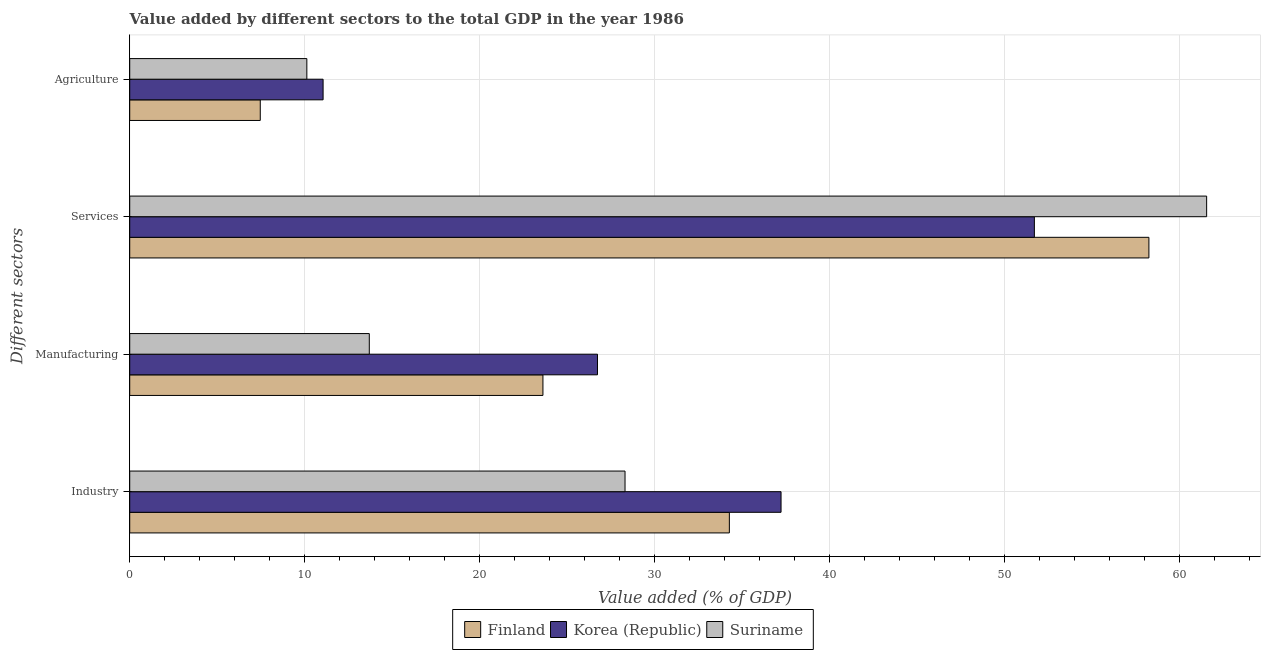How many groups of bars are there?
Keep it short and to the point. 4. Are the number of bars on each tick of the Y-axis equal?
Provide a succinct answer. Yes. How many bars are there on the 3rd tick from the bottom?
Your answer should be compact. 3. What is the label of the 4th group of bars from the top?
Your answer should be very brief. Industry. What is the value added by agricultural sector in Korea (Republic)?
Keep it short and to the point. 11.05. Across all countries, what is the maximum value added by industrial sector?
Provide a short and direct response. 37.23. Across all countries, what is the minimum value added by manufacturing sector?
Offer a terse response. 13.7. In which country was the value added by services sector maximum?
Keep it short and to the point. Suriname. In which country was the value added by manufacturing sector minimum?
Provide a succinct answer. Suriname. What is the total value added by manufacturing sector in the graph?
Give a very brief answer. 64.06. What is the difference between the value added by services sector in Suriname and that in Finland?
Keep it short and to the point. 3.3. What is the difference between the value added by manufacturing sector in Korea (Republic) and the value added by agricultural sector in Suriname?
Offer a very short reply. 16.61. What is the average value added by agricultural sector per country?
Offer a terse response. 9.55. What is the difference between the value added by services sector and value added by manufacturing sector in Finland?
Your answer should be very brief. 34.64. In how many countries, is the value added by manufacturing sector greater than 40 %?
Keep it short and to the point. 0. What is the ratio of the value added by manufacturing sector in Suriname to that in Korea (Republic)?
Keep it short and to the point. 0.51. What is the difference between the highest and the second highest value added by manufacturing sector?
Your response must be concise. 3.12. What is the difference between the highest and the lowest value added by industrial sector?
Provide a short and direct response. 8.92. What does the 1st bar from the bottom in Agriculture represents?
Make the answer very short. Finland. Is it the case that in every country, the sum of the value added by industrial sector and value added by manufacturing sector is greater than the value added by services sector?
Provide a short and direct response. No. Are all the bars in the graph horizontal?
Ensure brevity in your answer.  Yes. How many countries are there in the graph?
Your answer should be compact. 3. What is the difference between two consecutive major ticks on the X-axis?
Keep it short and to the point. 10. Are the values on the major ticks of X-axis written in scientific E-notation?
Ensure brevity in your answer.  No. Does the graph contain grids?
Your response must be concise. Yes. Where does the legend appear in the graph?
Offer a terse response. Bottom center. How many legend labels are there?
Make the answer very short. 3. What is the title of the graph?
Offer a very short reply. Value added by different sectors to the total GDP in the year 1986. Does "Vanuatu" appear as one of the legend labels in the graph?
Your answer should be compact. No. What is the label or title of the X-axis?
Offer a terse response. Value added (% of GDP). What is the label or title of the Y-axis?
Offer a terse response. Different sectors. What is the Value added (% of GDP) of Finland in Industry?
Your answer should be compact. 34.28. What is the Value added (% of GDP) of Korea (Republic) in Industry?
Your answer should be very brief. 37.23. What is the Value added (% of GDP) in Suriname in Industry?
Offer a very short reply. 28.31. What is the Value added (% of GDP) of Finland in Manufacturing?
Provide a succinct answer. 23.62. What is the Value added (% of GDP) in Korea (Republic) in Manufacturing?
Ensure brevity in your answer.  26.74. What is the Value added (% of GDP) of Suriname in Manufacturing?
Provide a succinct answer. 13.7. What is the Value added (% of GDP) in Finland in Services?
Ensure brevity in your answer.  58.26. What is the Value added (% of GDP) of Korea (Republic) in Services?
Your answer should be compact. 51.71. What is the Value added (% of GDP) of Suriname in Services?
Provide a short and direct response. 61.56. What is the Value added (% of GDP) in Finland in Agriculture?
Your answer should be very brief. 7.46. What is the Value added (% of GDP) of Korea (Republic) in Agriculture?
Provide a short and direct response. 11.05. What is the Value added (% of GDP) in Suriname in Agriculture?
Give a very brief answer. 10.12. Across all Different sectors, what is the maximum Value added (% of GDP) in Finland?
Provide a short and direct response. 58.26. Across all Different sectors, what is the maximum Value added (% of GDP) in Korea (Republic)?
Offer a terse response. 51.71. Across all Different sectors, what is the maximum Value added (% of GDP) of Suriname?
Offer a terse response. 61.56. Across all Different sectors, what is the minimum Value added (% of GDP) of Finland?
Give a very brief answer. 7.46. Across all Different sectors, what is the minimum Value added (% of GDP) in Korea (Republic)?
Your response must be concise. 11.05. Across all Different sectors, what is the minimum Value added (% of GDP) of Suriname?
Offer a very short reply. 10.12. What is the total Value added (% of GDP) of Finland in the graph?
Your answer should be compact. 123.62. What is the total Value added (% of GDP) in Korea (Republic) in the graph?
Your response must be concise. 126.74. What is the total Value added (% of GDP) in Suriname in the graph?
Offer a terse response. 113.7. What is the difference between the Value added (% of GDP) of Finland in Industry and that in Manufacturing?
Make the answer very short. 10.66. What is the difference between the Value added (% of GDP) of Korea (Republic) in Industry and that in Manufacturing?
Your response must be concise. 10.49. What is the difference between the Value added (% of GDP) of Suriname in Industry and that in Manufacturing?
Your answer should be very brief. 14.62. What is the difference between the Value added (% of GDP) of Finland in Industry and that in Services?
Your response must be concise. -23.98. What is the difference between the Value added (% of GDP) in Korea (Republic) in Industry and that in Services?
Offer a terse response. -14.48. What is the difference between the Value added (% of GDP) in Suriname in Industry and that in Services?
Keep it short and to the point. -33.25. What is the difference between the Value added (% of GDP) of Finland in Industry and that in Agriculture?
Keep it short and to the point. 26.82. What is the difference between the Value added (% of GDP) of Korea (Republic) in Industry and that in Agriculture?
Make the answer very short. 26.18. What is the difference between the Value added (% of GDP) of Suriname in Industry and that in Agriculture?
Provide a succinct answer. 18.19. What is the difference between the Value added (% of GDP) of Finland in Manufacturing and that in Services?
Offer a terse response. -34.64. What is the difference between the Value added (% of GDP) in Korea (Republic) in Manufacturing and that in Services?
Your answer should be compact. -24.97. What is the difference between the Value added (% of GDP) of Suriname in Manufacturing and that in Services?
Offer a terse response. -47.87. What is the difference between the Value added (% of GDP) in Finland in Manufacturing and that in Agriculture?
Keep it short and to the point. 16.16. What is the difference between the Value added (% of GDP) of Korea (Republic) in Manufacturing and that in Agriculture?
Your response must be concise. 15.69. What is the difference between the Value added (% of GDP) in Suriname in Manufacturing and that in Agriculture?
Your answer should be very brief. 3.57. What is the difference between the Value added (% of GDP) of Finland in Services and that in Agriculture?
Keep it short and to the point. 50.8. What is the difference between the Value added (% of GDP) in Korea (Republic) in Services and that in Agriculture?
Ensure brevity in your answer.  40.66. What is the difference between the Value added (% of GDP) of Suriname in Services and that in Agriculture?
Make the answer very short. 51.44. What is the difference between the Value added (% of GDP) in Finland in Industry and the Value added (% of GDP) in Korea (Republic) in Manufacturing?
Ensure brevity in your answer.  7.54. What is the difference between the Value added (% of GDP) in Finland in Industry and the Value added (% of GDP) in Suriname in Manufacturing?
Make the answer very short. 20.58. What is the difference between the Value added (% of GDP) of Korea (Republic) in Industry and the Value added (% of GDP) of Suriname in Manufacturing?
Make the answer very short. 23.54. What is the difference between the Value added (% of GDP) of Finland in Industry and the Value added (% of GDP) of Korea (Republic) in Services?
Offer a terse response. -17.44. What is the difference between the Value added (% of GDP) in Finland in Industry and the Value added (% of GDP) in Suriname in Services?
Make the answer very short. -27.28. What is the difference between the Value added (% of GDP) in Korea (Republic) in Industry and the Value added (% of GDP) in Suriname in Services?
Your answer should be very brief. -24.33. What is the difference between the Value added (% of GDP) in Finland in Industry and the Value added (% of GDP) in Korea (Republic) in Agriculture?
Keep it short and to the point. 23.22. What is the difference between the Value added (% of GDP) of Finland in Industry and the Value added (% of GDP) of Suriname in Agriculture?
Provide a short and direct response. 24.15. What is the difference between the Value added (% of GDP) of Korea (Republic) in Industry and the Value added (% of GDP) of Suriname in Agriculture?
Ensure brevity in your answer.  27.11. What is the difference between the Value added (% of GDP) in Finland in Manufacturing and the Value added (% of GDP) in Korea (Republic) in Services?
Give a very brief answer. -28.09. What is the difference between the Value added (% of GDP) in Finland in Manufacturing and the Value added (% of GDP) in Suriname in Services?
Make the answer very short. -37.94. What is the difference between the Value added (% of GDP) in Korea (Republic) in Manufacturing and the Value added (% of GDP) in Suriname in Services?
Make the answer very short. -34.82. What is the difference between the Value added (% of GDP) of Finland in Manufacturing and the Value added (% of GDP) of Korea (Republic) in Agriculture?
Your response must be concise. 12.57. What is the difference between the Value added (% of GDP) of Finland in Manufacturing and the Value added (% of GDP) of Suriname in Agriculture?
Give a very brief answer. 13.5. What is the difference between the Value added (% of GDP) of Korea (Republic) in Manufacturing and the Value added (% of GDP) of Suriname in Agriculture?
Provide a succinct answer. 16.61. What is the difference between the Value added (% of GDP) in Finland in Services and the Value added (% of GDP) in Korea (Republic) in Agriculture?
Make the answer very short. 47.21. What is the difference between the Value added (% of GDP) of Finland in Services and the Value added (% of GDP) of Suriname in Agriculture?
Offer a very short reply. 48.14. What is the difference between the Value added (% of GDP) in Korea (Republic) in Services and the Value added (% of GDP) in Suriname in Agriculture?
Give a very brief answer. 41.59. What is the average Value added (% of GDP) in Finland per Different sectors?
Provide a succinct answer. 30.91. What is the average Value added (% of GDP) of Korea (Republic) per Different sectors?
Your answer should be compact. 31.68. What is the average Value added (% of GDP) in Suriname per Different sectors?
Provide a short and direct response. 28.42. What is the difference between the Value added (% of GDP) of Finland and Value added (% of GDP) of Korea (Republic) in Industry?
Your answer should be very brief. -2.95. What is the difference between the Value added (% of GDP) in Finland and Value added (% of GDP) in Suriname in Industry?
Make the answer very short. 5.96. What is the difference between the Value added (% of GDP) of Korea (Republic) and Value added (% of GDP) of Suriname in Industry?
Offer a very short reply. 8.92. What is the difference between the Value added (% of GDP) in Finland and Value added (% of GDP) in Korea (Republic) in Manufacturing?
Keep it short and to the point. -3.12. What is the difference between the Value added (% of GDP) of Finland and Value added (% of GDP) of Suriname in Manufacturing?
Offer a very short reply. 9.93. What is the difference between the Value added (% of GDP) of Korea (Republic) and Value added (% of GDP) of Suriname in Manufacturing?
Give a very brief answer. 13.04. What is the difference between the Value added (% of GDP) in Finland and Value added (% of GDP) in Korea (Republic) in Services?
Give a very brief answer. 6.55. What is the difference between the Value added (% of GDP) in Finland and Value added (% of GDP) in Suriname in Services?
Make the answer very short. -3.3. What is the difference between the Value added (% of GDP) of Korea (Republic) and Value added (% of GDP) of Suriname in Services?
Keep it short and to the point. -9.85. What is the difference between the Value added (% of GDP) of Finland and Value added (% of GDP) of Korea (Republic) in Agriculture?
Your response must be concise. -3.59. What is the difference between the Value added (% of GDP) in Finland and Value added (% of GDP) in Suriname in Agriculture?
Provide a short and direct response. -2.66. What is the difference between the Value added (% of GDP) in Korea (Republic) and Value added (% of GDP) in Suriname in Agriculture?
Make the answer very short. 0.93. What is the ratio of the Value added (% of GDP) in Finland in Industry to that in Manufacturing?
Provide a short and direct response. 1.45. What is the ratio of the Value added (% of GDP) in Korea (Republic) in Industry to that in Manufacturing?
Make the answer very short. 1.39. What is the ratio of the Value added (% of GDP) in Suriname in Industry to that in Manufacturing?
Make the answer very short. 2.07. What is the ratio of the Value added (% of GDP) of Finland in Industry to that in Services?
Your answer should be compact. 0.59. What is the ratio of the Value added (% of GDP) of Korea (Republic) in Industry to that in Services?
Make the answer very short. 0.72. What is the ratio of the Value added (% of GDP) in Suriname in Industry to that in Services?
Provide a succinct answer. 0.46. What is the ratio of the Value added (% of GDP) in Finland in Industry to that in Agriculture?
Your response must be concise. 4.59. What is the ratio of the Value added (% of GDP) of Korea (Republic) in Industry to that in Agriculture?
Your answer should be compact. 3.37. What is the ratio of the Value added (% of GDP) of Suriname in Industry to that in Agriculture?
Provide a short and direct response. 2.8. What is the ratio of the Value added (% of GDP) of Finland in Manufacturing to that in Services?
Offer a very short reply. 0.41. What is the ratio of the Value added (% of GDP) of Korea (Republic) in Manufacturing to that in Services?
Your response must be concise. 0.52. What is the ratio of the Value added (% of GDP) in Suriname in Manufacturing to that in Services?
Your response must be concise. 0.22. What is the ratio of the Value added (% of GDP) in Finland in Manufacturing to that in Agriculture?
Provide a succinct answer. 3.17. What is the ratio of the Value added (% of GDP) in Korea (Republic) in Manufacturing to that in Agriculture?
Your answer should be very brief. 2.42. What is the ratio of the Value added (% of GDP) in Suriname in Manufacturing to that in Agriculture?
Offer a very short reply. 1.35. What is the ratio of the Value added (% of GDP) of Finland in Services to that in Agriculture?
Your answer should be very brief. 7.81. What is the ratio of the Value added (% of GDP) in Korea (Republic) in Services to that in Agriculture?
Make the answer very short. 4.68. What is the ratio of the Value added (% of GDP) in Suriname in Services to that in Agriculture?
Keep it short and to the point. 6.08. What is the difference between the highest and the second highest Value added (% of GDP) in Finland?
Keep it short and to the point. 23.98. What is the difference between the highest and the second highest Value added (% of GDP) of Korea (Republic)?
Your answer should be very brief. 14.48. What is the difference between the highest and the second highest Value added (% of GDP) of Suriname?
Give a very brief answer. 33.25. What is the difference between the highest and the lowest Value added (% of GDP) of Finland?
Make the answer very short. 50.8. What is the difference between the highest and the lowest Value added (% of GDP) of Korea (Republic)?
Keep it short and to the point. 40.66. What is the difference between the highest and the lowest Value added (% of GDP) of Suriname?
Ensure brevity in your answer.  51.44. 